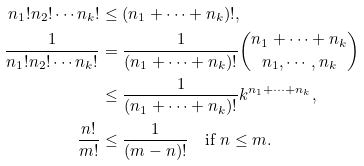<formula> <loc_0><loc_0><loc_500><loc_500>n _ { 1 } ! n _ { 2 } ! \cdots n _ { k } ! & \leq ( n _ { 1 } + \cdots + n _ { k } ) ! , \\ \frac { 1 } { n _ { 1 } ! n _ { 2 } ! \cdots n _ { k } ! } & = \frac { 1 } { ( n _ { 1 } + \cdots + n _ { k } ) ! } \binom { n _ { 1 } + \cdots + n _ { k } } { n _ { 1 } , \cdots , n _ { k } } \\ & \leq \frac { 1 } { ( n _ { 1 } + \cdots + n _ { k } ) ! } k ^ { n _ { 1 } + \cdots + n _ { k } } , \\ \frac { n ! } { m ! } & \leq \frac { 1 } { ( m - n ) ! } \text {\quad if } n \leq m .</formula> 